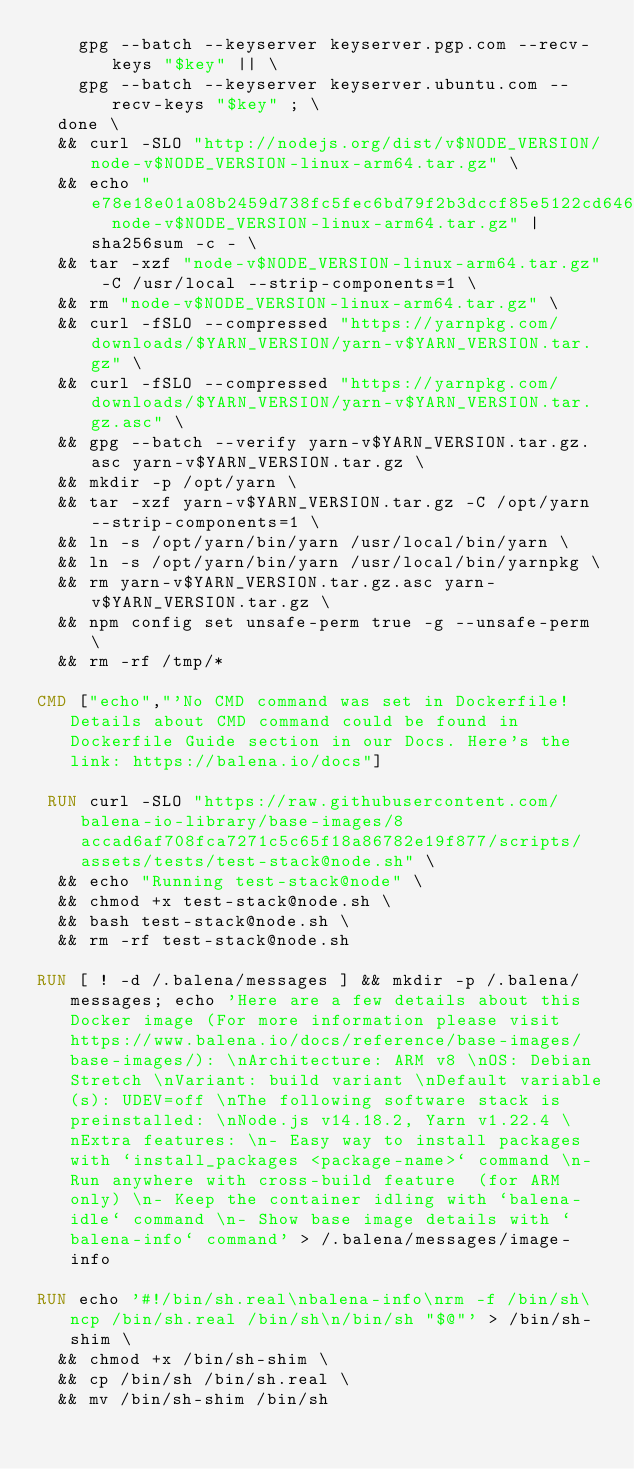<code> <loc_0><loc_0><loc_500><loc_500><_Dockerfile_>		gpg --batch --keyserver keyserver.pgp.com --recv-keys "$key" || \
		gpg --batch --keyserver keyserver.ubuntu.com --recv-keys "$key" ; \
	done \
	&& curl -SLO "http://nodejs.org/dist/v$NODE_VERSION/node-v$NODE_VERSION-linux-arm64.tar.gz" \
	&& echo "e78e18e01a08b2459d738fc5fec6bd79f2b3dccf85e5122cd646b3385964bc1e  node-v$NODE_VERSION-linux-arm64.tar.gz" | sha256sum -c - \
	&& tar -xzf "node-v$NODE_VERSION-linux-arm64.tar.gz" -C /usr/local --strip-components=1 \
	&& rm "node-v$NODE_VERSION-linux-arm64.tar.gz" \
	&& curl -fSLO --compressed "https://yarnpkg.com/downloads/$YARN_VERSION/yarn-v$YARN_VERSION.tar.gz" \
	&& curl -fSLO --compressed "https://yarnpkg.com/downloads/$YARN_VERSION/yarn-v$YARN_VERSION.tar.gz.asc" \
	&& gpg --batch --verify yarn-v$YARN_VERSION.tar.gz.asc yarn-v$YARN_VERSION.tar.gz \
	&& mkdir -p /opt/yarn \
	&& tar -xzf yarn-v$YARN_VERSION.tar.gz -C /opt/yarn --strip-components=1 \
	&& ln -s /opt/yarn/bin/yarn /usr/local/bin/yarn \
	&& ln -s /opt/yarn/bin/yarn /usr/local/bin/yarnpkg \
	&& rm yarn-v$YARN_VERSION.tar.gz.asc yarn-v$YARN_VERSION.tar.gz \
	&& npm config set unsafe-perm true -g --unsafe-perm \
	&& rm -rf /tmp/*

CMD ["echo","'No CMD command was set in Dockerfile! Details about CMD command could be found in Dockerfile Guide section in our Docs. Here's the link: https://balena.io/docs"]

 RUN curl -SLO "https://raw.githubusercontent.com/balena-io-library/base-images/8accad6af708fca7271c5c65f18a86782e19f877/scripts/assets/tests/test-stack@node.sh" \
  && echo "Running test-stack@node" \
  && chmod +x test-stack@node.sh \
  && bash test-stack@node.sh \
  && rm -rf test-stack@node.sh 

RUN [ ! -d /.balena/messages ] && mkdir -p /.balena/messages; echo 'Here are a few details about this Docker image (For more information please visit https://www.balena.io/docs/reference/base-images/base-images/): \nArchitecture: ARM v8 \nOS: Debian Stretch \nVariant: build variant \nDefault variable(s): UDEV=off \nThe following software stack is preinstalled: \nNode.js v14.18.2, Yarn v1.22.4 \nExtra features: \n- Easy way to install packages with `install_packages <package-name>` command \n- Run anywhere with cross-build feature  (for ARM only) \n- Keep the container idling with `balena-idle` command \n- Show base image details with `balena-info` command' > /.balena/messages/image-info

RUN echo '#!/bin/sh.real\nbalena-info\nrm -f /bin/sh\ncp /bin/sh.real /bin/sh\n/bin/sh "$@"' > /bin/sh-shim \
	&& chmod +x /bin/sh-shim \
	&& cp /bin/sh /bin/sh.real \
	&& mv /bin/sh-shim /bin/sh</code> 